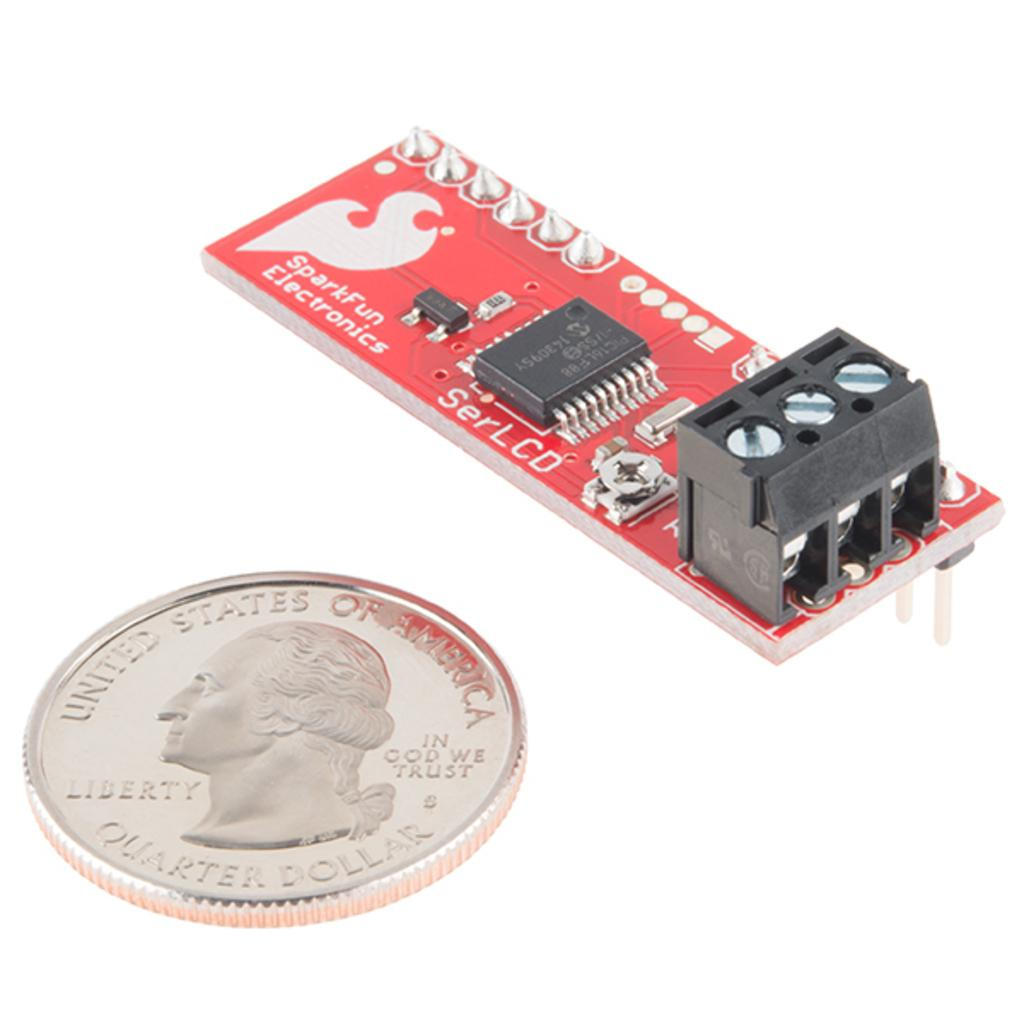<image>
Give a short and clear explanation of the subsequent image. A electronic device being compared to the size of a quarter. 